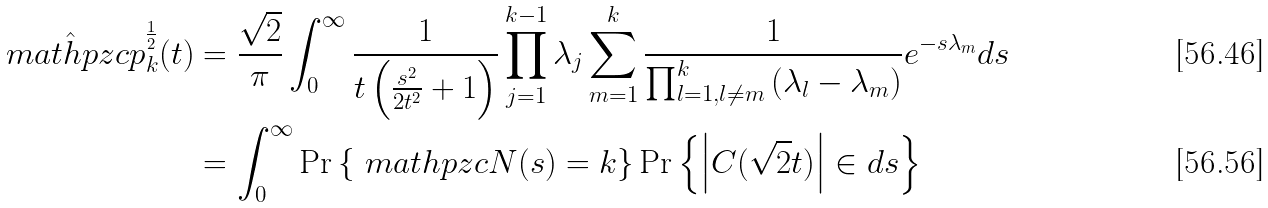<formula> <loc_0><loc_0><loc_500><loc_500>\hat { \ m a t h p z c { p } } _ { k } ^ { \frac { 1 } { 2 } } ( t ) & = \frac { \sqrt { 2 } } { \pi } \int _ { 0 } ^ { \infty } \frac { 1 } { t \left ( \frac { s ^ { 2 } } { 2 t ^ { 2 } } + 1 \right ) } \prod _ { j = 1 } ^ { k - 1 } \lambda _ { j } \sum _ { m = 1 } ^ { k } \frac { 1 } { \prod _ { l = 1 , l \neq m } ^ { k } \left ( \lambda _ { l } - \lambda _ { m } \right ) } e ^ { - s \lambda _ { m } } d s \\ & = \int _ { 0 } ^ { \infty } \text {Pr} \left \{ \ m a t h p z c { N } ( s ) = k \right \} \text {Pr} \left \{ \left | C ( \sqrt { 2 } t ) \right | \in d s \right \}</formula> 